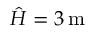Convert formula to latex. <formula><loc_0><loc_0><loc_500><loc_500>\hat { H } = 3 \, m</formula> 